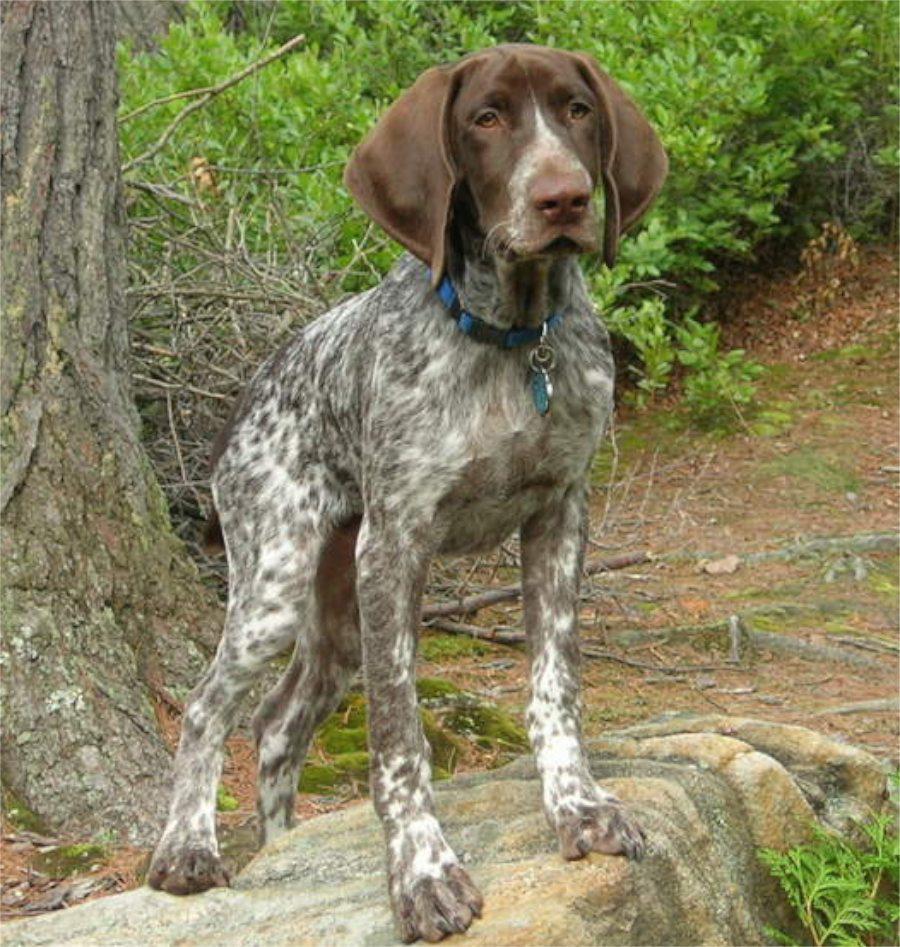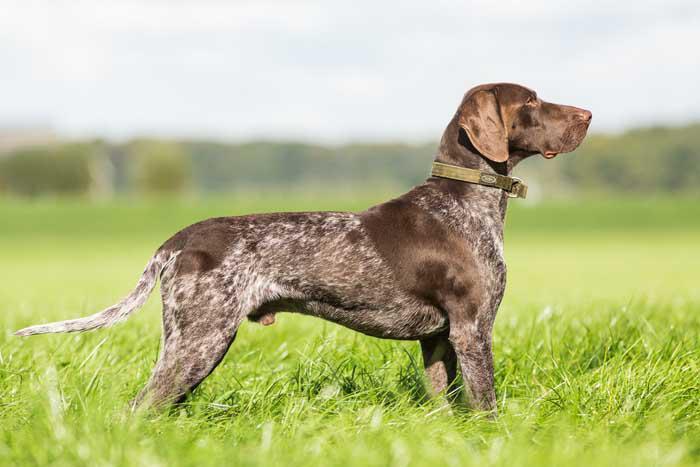The first image is the image on the left, the second image is the image on the right. Examine the images to the left and right. Is the description "The dogs in both images are wearing collars." accurate? Answer yes or no. Yes. The first image is the image on the left, the second image is the image on the right. Evaluate the accuracy of this statement regarding the images: "In one of the images, there is a dog wearing an orange collar.". Is it true? Answer yes or no. No. 